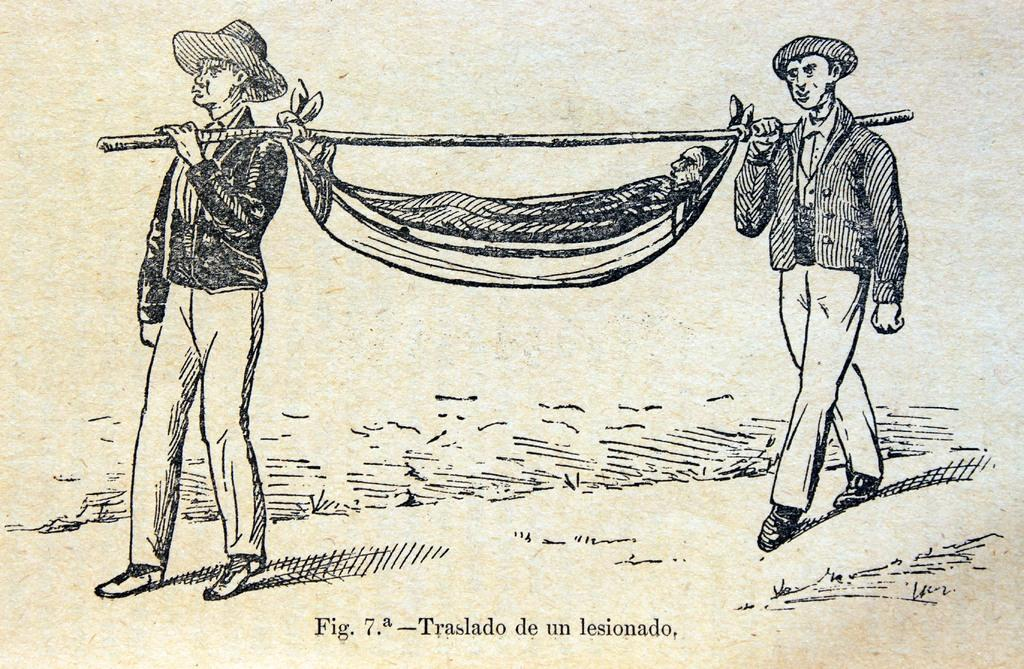How many people are in the image? There are two men in the image. What are the two men doing? The two men are walking. What are the men carrying? The men are carrying a person on a stick. What type of calculator is the person on the stick using in the image? There is no calculator present in the image; the men are carrying a person on a stick. What kind of test is the person on the stick taking in the image? There is no test being taken in the image; the men are carrying a person on a stick. 